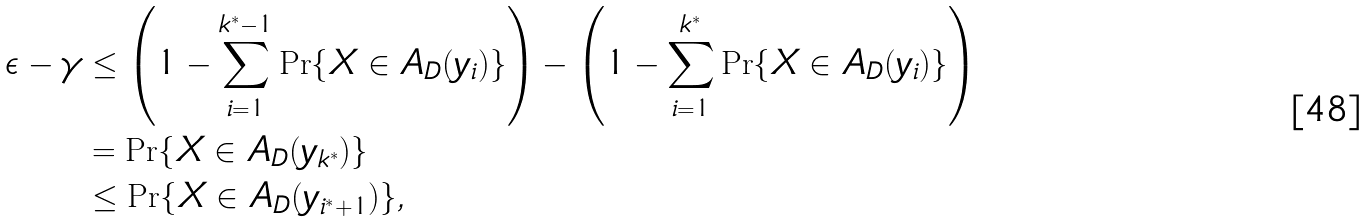Convert formula to latex. <formula><loc_0><loc_0><loc_500><loc_500>\epsilon - \gamma & \leq \left ( 1 - \sum _ { i = 1 } ^ { k ^ { * } - 1 } \Pr \{ X \in A _ { D } ( y _ { i } ) \} \right ) - \left ( 1 - \sum _ { i = 1 } ^ { k ^ { * } } \Pr \{ X \in A _ { D } ( y _ { i } ) \} \right ) \\ & = \Pr \{ X \in A _ { D } ( y _ { k ^ { * } } ) \} \\ & \leq \Pr \{ X \in A _ { D } ( y _ { i ^ { * } + 1 } ) \} ,</formula> 